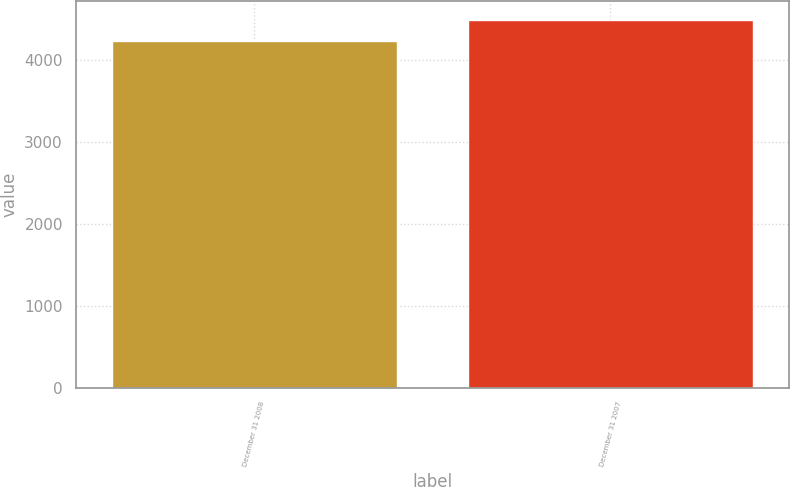Convert chart. <chart><loc_0><loc_0><loc_500><loc_500><bar_chart><fcel>December 31 2008<fcel>December 31 2007<nl><fcel>4238<fcel>4499<nl></chart> 